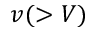Convert formula to latex. <formula><loc_0><loc_0><loc_500><loc_500>v ( > V )</formula> 